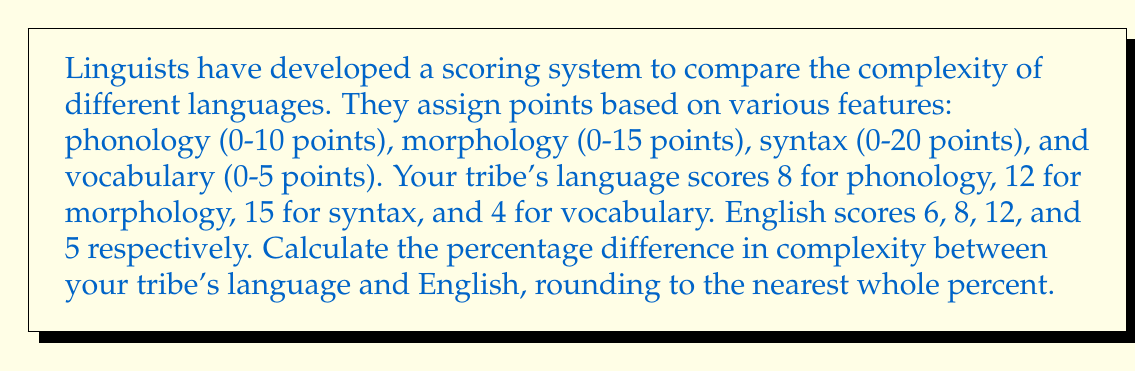What is the answer to this math problem? 1. Calculate the total complexity score for your tribe's language:
   $$8 + 12 + 15 + 4 = 39$$

2. Calculate the total complexity score for English:
   $$6 + 8 + 12 + 5 = 31$$

3. Find the difference in complexity:
   $$39 - 31 = 8$$

4. Calculate the percentage difference:
   $$\frac{\text{Difference}}{\text{English Score}} \times 100 = \frac{8}{31} \times 100 \approx 25.8065\%$$

5. Round to the nearest whole percent:
   $$25.8065\% \approx 26\%$$
Answer: 26% 